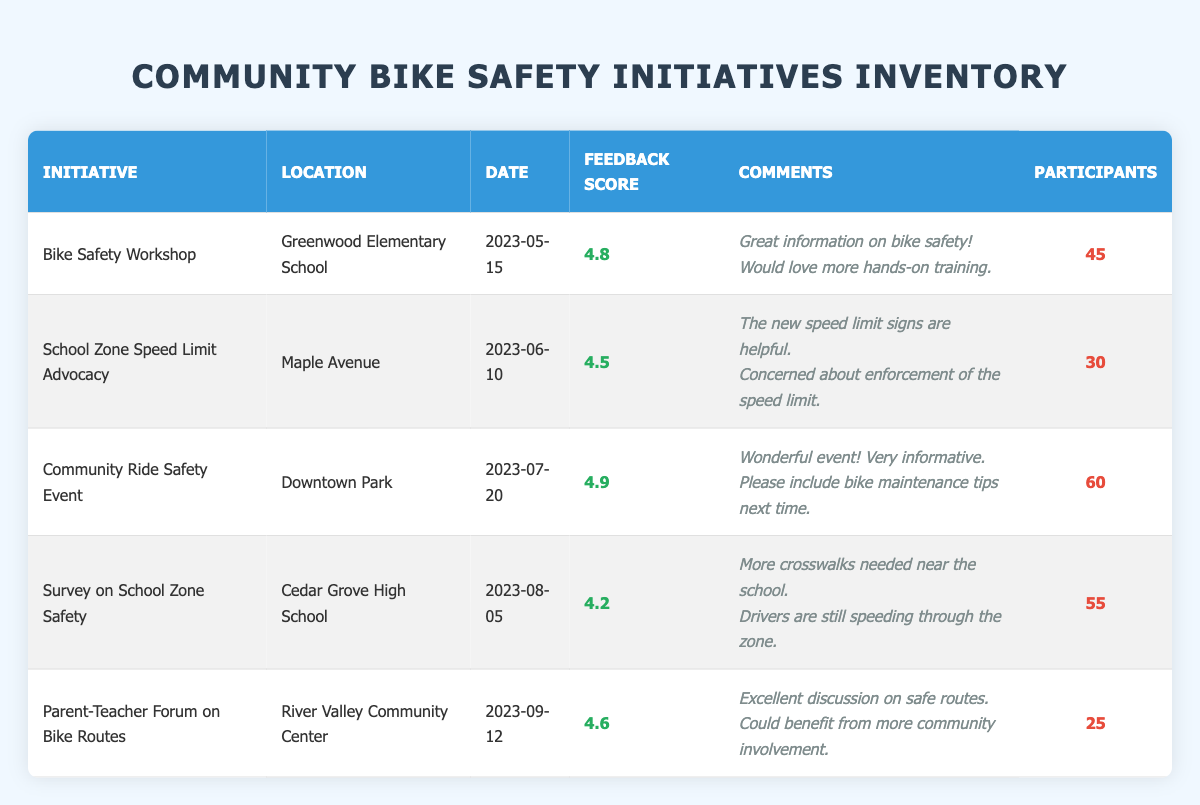What was the feedback score for the Community Ride Safety Event? The feedback score for the Community Ride Safety Event, as shown in the table, is listed directly under the Feedback Score column for that initiative, which is 4.9.
Answer: 4.9 Which initiative had the highest participant count? By looking at the Participant Count column, the Community Ride Safety Event had the highest participant count of 60.
Answer: 60 Is the feedback score for the Survey on School Zone Safety greater than 4.5? The feedback score for the Survey on School Zone Safety is 4.2, which is less than 4.5. Therefore, the answer is no.
Answer: No What is the average feedback score for all initiatives listed? To find the average feedback score, sum all the scores: 4.8 + 4.5 + 4.9 + 4.2 + 4.6 = 23.0. There are 5 initiatives, so the average is 23.0 / 5 = 4.6.
Answer: 4.6 How many total participants attended the bike safety workshops noted in the table? The table specifies participant counts for several initiatives, but focusing on the bike safety workshops (Bike Safety Workshop with 45 participants and Community Ride Safety Event with 60 participants), the total is 45 + 60 = 105.
Answer: 105 Which initiative received comments about needing more hands-on training? The comments for the Bike Safety Workshop mention a desire for more hands-on training, thus identifying this initiative.
Answer: Bike Safety Workshop Was there any initiative with comments suggesting improvements regarding school zone safety? Yes, the Survey on School Zone Safety had comments stating that more crosswalks are needed and that drivers are still speeding through the zone. Therefore, the answer is yes.
Answer: Yes What was the feedback score difference between the highest and lowest scoring initiatives? The highest scoring initiative is the Community Ride Safety Event (4.9) and the lowest is the Survey on School Zone Safety (4.2). The difference is calculated as 4.9 - 4.2 = 0.7.
Answer: 0.7 List the initiative that had comments about needing more community involvement. The Parent-Teacher Forum on Bike Routes received comments stating it could benefit from more community involvement; therefore, this initiative is the answer.
Answer: Parent-Teacher Forum on Bike Routes 